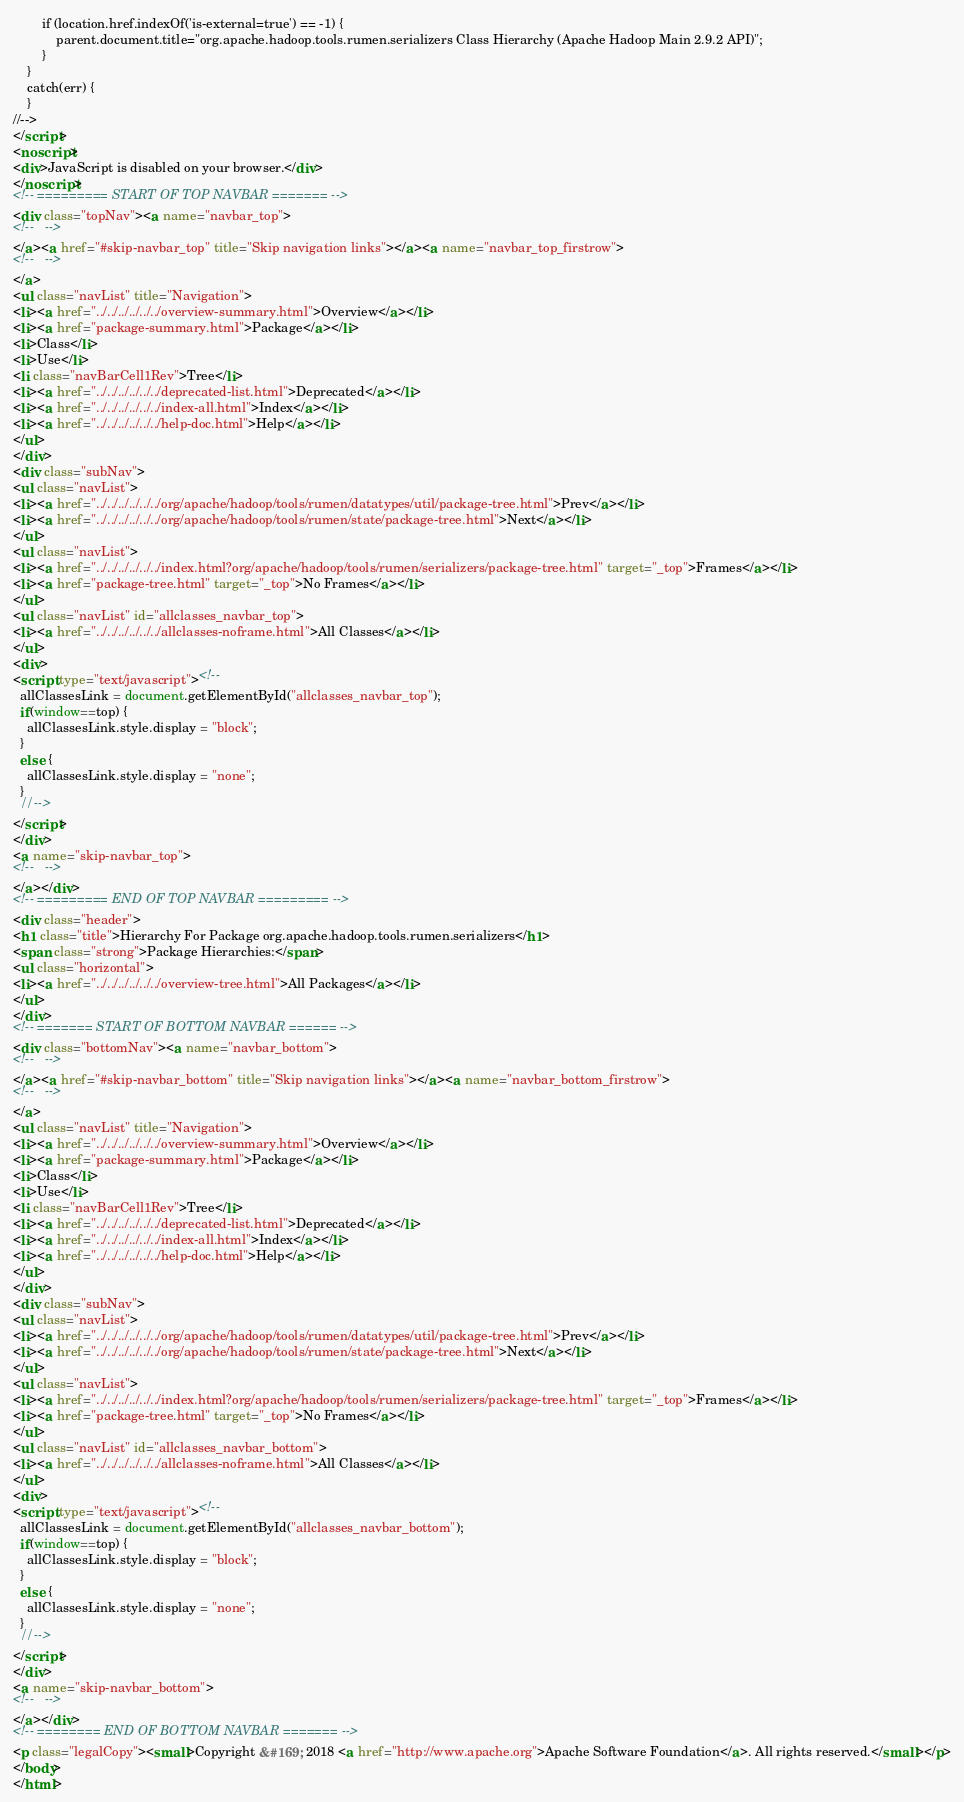<code> <loc_0><loc_0><loc_500><loc_500><_HTML_>        if (location.href.indexOf('is-external=true') == -1) {
            parent.document.title="org.apache.hadoop.tools.rumen.serializers Class Hierarchy (Apache Hadoop Main 2.9.2 API)";
        }
    }
    catch(err) {
    }
//-->
</script>
<noscript>
<div>JavaScript is disabled on your browser.</div>
</noscript>
<!-- ========= START OF TOP NAVBAR ======= -->
<div class="topNav"><a name="navbar_top">
<!--   -->
</a><a href="#skip-navbar_top" title="Skip navigation links"></a><a name="navbar_top_firstrow">
<!--   -->
</a>
<ul class="navList" title="Navigation">
<li><a href="../../../../../../overview-summary.html">Overview</a></li>
<li><a href="package-summary.html">Package</a></li>
<li>Class</li>
<li>Use</li>
<li class="navBarCell1Rev">Tree</li>
<li><a href="../../../../../../deprecated-list.html">Deprecated</a></li>
<li><a href="../../../../../../index-all.html">Index</a></li>
<li><a href="../../../../../../help-doc.html">Help</a></li>
</ul>
</div>
<div class="subNav">
<ul class="navList">
<li><a href="../../../../../../org/apache/hadoop/tools/rumen/datatypes/util/package-tree.html">Prev</a></li>
<li><a href="../../../../../../org/apache/hadoop/tools/rumen/state/package-tree.html">Next</a></li>
</ul>
<ul class="navList">
<li><a href="../../../../../../index.html?org/apache/hadoop/tools/rumen/serializers/package-tree.html" target="_top">Frames</a></li>
<li><a href="package-tree.html" target="_top">No Frames</a></li>
</ul>
<ul class="navList" id="allclasses_navbar_top">
<li><a href="../../../../../../allclasses-noframe.html">All Classes</a></li>
</ul>
<div>
<script type="text/javascript"><!--
  allClassesLink = document.getElementById("allclasses_navbar_top");
  if(window==top) {
    allClassesLink.style.display = "block";
  }
  else {
    allClassesLink.style.display = "none";
  }
  //-->
</script>
</div>
<a name="skip-navbar_top">
<!--   -->
</a></div>
<!-- ========= END OF TOP NAVBAR ========= -->
<div class="header">
<h1 class="title">Hierarchy For Package org.apache.hadoop.tools.rumen.serializers</h1>
<span class="strong">Package Hierarchies:</span>
<ul class="horizontal">
<li><a href="../../../../../../overview-tree.html">All Packages</a></li>
</ul>
</div>
<!-- ======= START OF BOTTOM NAVBAR ====== -->
<div class="bottomNav"><a name="navbar_bottom">
<!--   -->
</a><a href="#skip-navbar_bottom" title="Skip navigation links"></a><a name="navbar_bottom_firstrow">
<!--   -->
</a>
<ul class="navList" title="Navigation">
<li><a href="../../../../../../overview-summary.html">Overview</a></li>
<li><a href="package-summary.html">Package</a></li>
<li>Class</li>
<li>Use</li>
<li class="navBarCell1Rev">Tree</li>
<li><a href="../../../../../../deprecated-list.html">Deprecated</a></li>
<li><a href="../../../../../../index-all.html">Index</a></li>
<li><a href="../../../../../../help-doc.html">Help</a></li>
</ul>
</div>
<div class="subNav">
<ul class="navList">
<li><a href="../../../../../../org/apache/hadoop/tools/rumen/datatypes/util/package-tree.html">Prev</a></li>
<li><a href="../../../../../../org/apache/hadoop/tools/rumen/state/package-tree.html">Next</a></li>
</ul>
<ul class="navList">
<li><a href="../../../../../../index.html?org/apache/hadoop/tools/rumen/serializers/package-tree.html" target="_top">Frames</a></li>
<li><a href="package-tree.html" target="_top">No Frames</a></li>
</ul>
<ul class="navList" id="allclasses_navbar_bottom">
<li><a href="../../../../../../allclasses-noframe.html">All Classes</a></li>
</ul>
<div>
<script type="text/javascript"><!--
  allClassesLink = document.getElementById("allclasses_navbar_bottom");
  if(window==top) {
    allClassesLink.style.display = "block";
  }
  else {
    allClassesLink.style.display = "none";
  }
  //-->
</script>
</div>
<a name="skip-navbar_bottom">
<!--   -->
</a></div>
<!-- ======== END OF BOTTOM NAVBAR ======= -->
<p class="legalCopy"><small>Copyright &#169; 2018 <a href="http://www.apache.org">Apache Software Foundation</a>. All rights reserved.</small></p>
</body>
</html>
</code> 